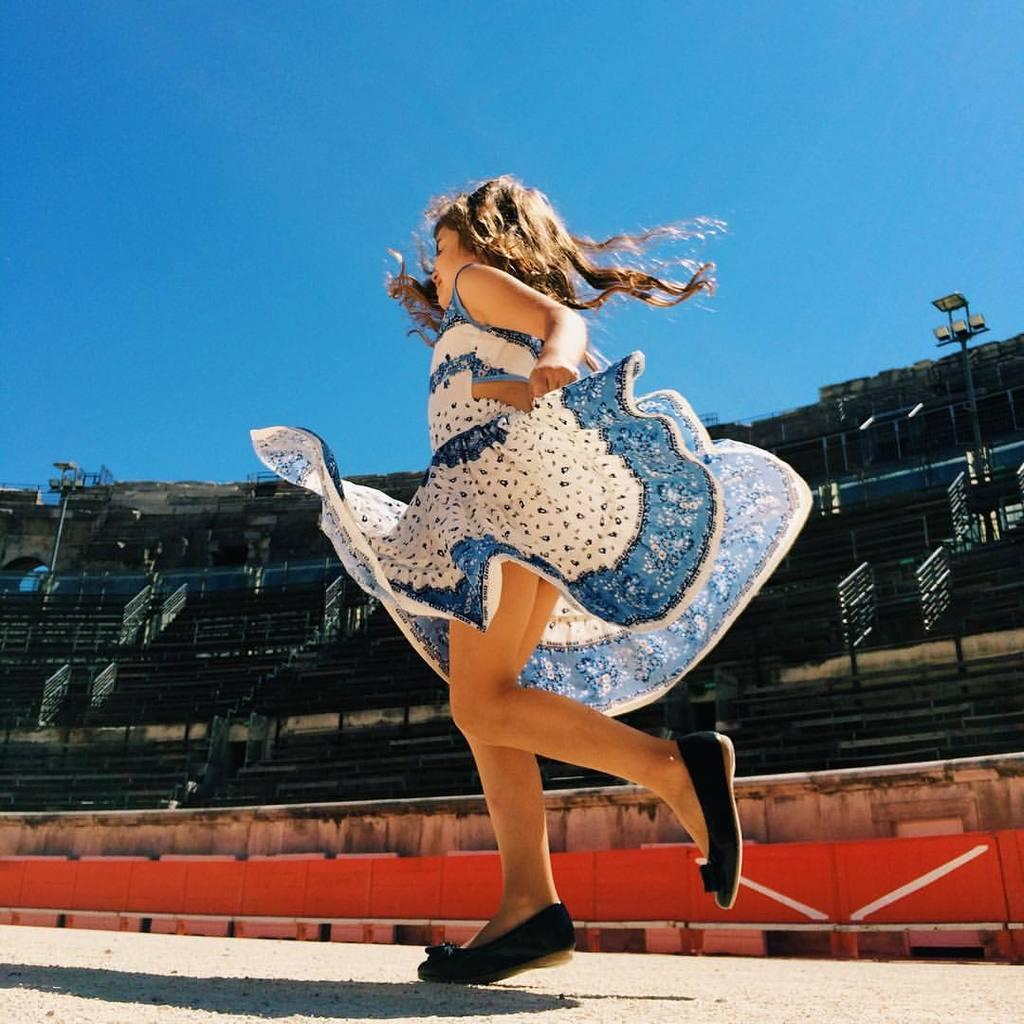Who is the main subject in the image? There is a girl in the image. What is the girl doing in the image? The girl is running on a pathway. What can be seen in the background of the image? There is a stadium in the background of the image. What features are present in the stadium? The stadium has benches, floodlights, and iron grilles. What is visible in the sky in the background of the image? The sky is visible in the background of the image. What type of appliance can be seen in the image? There is no appliance present in the image. What type of prison can be seen in the image? There is no prison present in the image. 